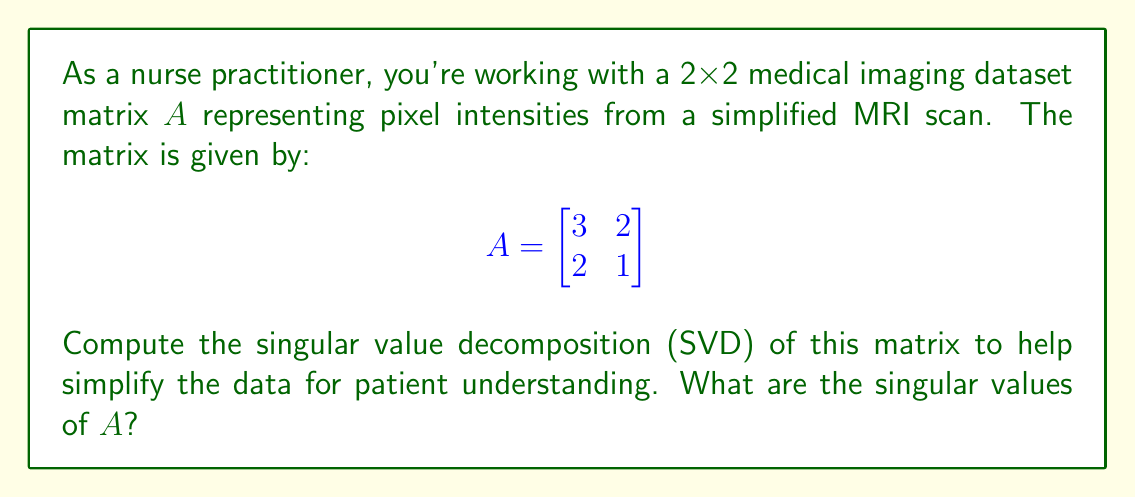Could you help me with this problem? To compute the singular value decomposition (SVD) of matrix $A$, we follow these steps:

1) First, calculate $A^TA$:
   $$A^TA = \begin{bmatrix}
   3 & 2 \\
   2 & 1
   \end{bmatrix}
   \begin{bmatrix}
   3 & 2 \\
   2 & 1
   \end{bmatrix}
   = \begin{bmatrix}
   13 & 8 \\
   8 & 5
   \end{bmatrix}$$

2) Find the eigenvalues of $A^TA$ by solving the characteristic equation:
   $det(A^TA - \lambda I) = 0$
   $\begin{vmatrix}
   13-\lambda & 8 \\
   8 & 5-\lambda
   \end{vmatrix} = 0$
   $(13-\lambda)(5-\lambda) - 64 = 0$
   $\lambda^2 - 18\lambda + 1 = 0$

3) Solve this quadratic equation:
   $\lambda = \frac{18 \pm \sqrt{324 - 4}}{2} = \frac{18 \pm \sqrt{320}}{2} = \frac{18 \pm 4\sqrt{5}}{2}$

4) The eigenvalues are:
   $\lambda_1 = 9 + 2\sqrt{5}$ and $\lambda_2 = 9 - 2\sqrt{5}$

5) The singular values are the square roots of these eigenvalues:
   $\sigma_1 = \sqrt{9 + 2\sqrt{5}}$ and $\sigma_2 = \sqrt{9 - 2\sqrt{5}}$

These singular values represent the importance of different components in the medical image, which can be used to simplify the data for patient understanding.
Answer: $\sigma_1 = \sqrt{9 + 2\sqrt{5}}$, $\sigma_2 = \sqrt{9 - 2\sqrt{5}}$ 